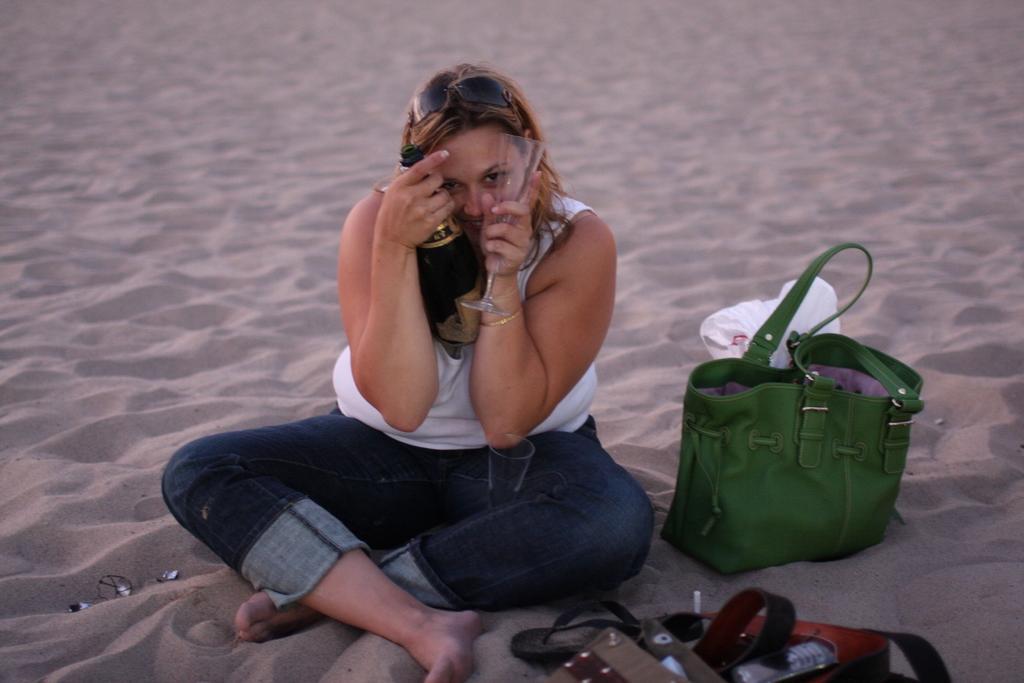Can you describe this image briefly? She is sitting on a sand. She is holding a glass and wine bottle. We can see the background is bag ,belt. 